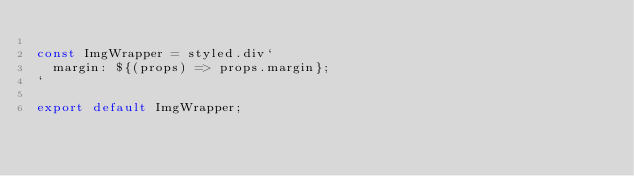Convert code to text. <code><loc_0><loc_0><loc_500><loc_500><_JavaScript_>
const ImgWrapper = styled.div`
  margin: ${(props) => props.margin};
`

export default ImgWrapper;
</code> 